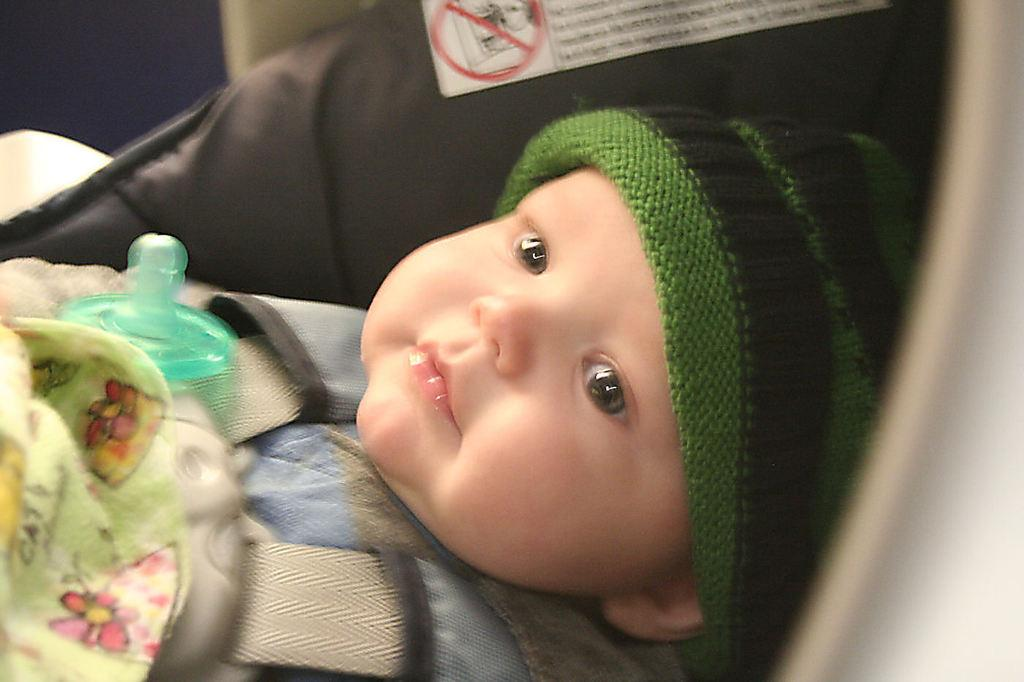What is the main subject of the image? There is a baby in the image. What is the baby wearing on their head? The baby is wearing a cap. What other item can be seen in the image? There is a handkerchief in the image. What might the baby be using to drink or eat? There is a bottle in the image, which the baby might be using to drink or eat. Can you see any yaks in the image? No, there are no yaks present in the image. What type of underwear is the baby wearing in the image? There is no information about the baby's underwear in the image, as the focus is on the cap and other visible items. 